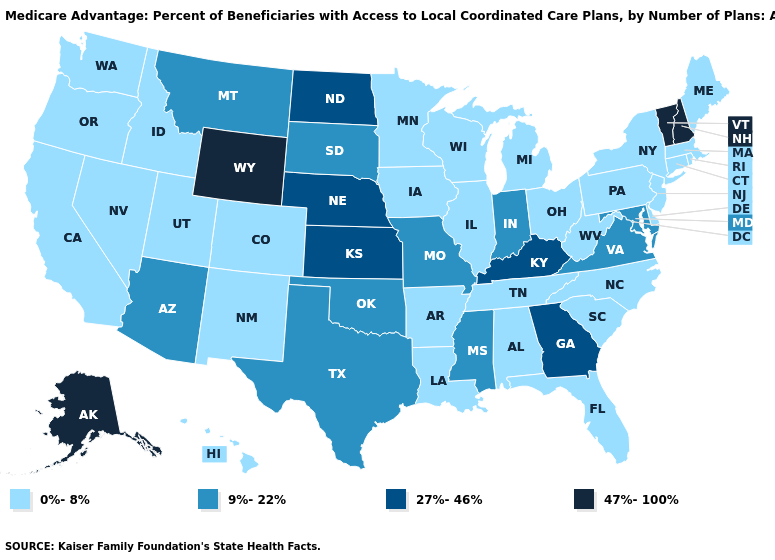What is the lowest value in the MidWest?
Quick response, please. 0%-8%. Does West Virginia have the lowest value in the USA?
Keep it brief. Yes. Name the states that have a value in the range 0%-8%?
Be succinct. Alabama, Arkansas, California, Colorado, Connecticut, Delaware, Florida, Hawaii, Iowa, Idaho, Illinois, Louisiana, Massachusetts, Maine, Michigan, Minnesota, North Carolina, New Jersey, New Mexico, Nevada, New York, Ohio, Oregon, Pennsylvania, Rhode Island, South Carolina, Tennessee, Utah, Washington, Wisconsin, West Virginia. Does Washington have the same value as Utah?
Keep it brief. Yes. Does North Dakota have the lowest value in the MidWest?
Concise answer only. No. What is the lowest value in states that border Missouri?
Quick response, please. 0%-8%. Does Georgia have the highest value in the USA?
Quick response, please. No. Which states have the highest value in the USA?
Concise answer only. Alaska, New Hampshire, Vermont, Wyoming. Does the map have missing data?
Quick response, please. No. Which states have the highest value in the USA?
Give a very brief answer. Alaska, New Hampshire, Vermont, Wyoming. Is the legend a continuous bar?
Concise answer only. No. Name the states that have a value in the range 9%-22%?
Short answer required. Arizona, Indiana, Maryland, Missouri, Mississippi, Montana, Oklahoma, South Dakota, Texas, Virginia. Among the states that border Indiana , which have the lowest value?
Quick response, please. Illinois, Michigan, Ohio. How many symbols are there in the legend?
Short answer required. 4. 